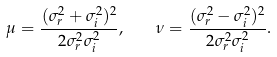Convert formula to latex. <formula><loc_0><loc_0><loc_500><loc_500>\mu = \frac { ( \sigma _ { r } ^ { 2 } + \sigma _ { i } ^ { 2 } ) ^ { 2 } } { 2 \sigma _ { r } ^ { 2 } \sigma _ { i } ^ { 2 } } , \quad \nu = \frac { ( \sigma _ { r } ^ { 2 } - \sigma _ { i } ^ { 2 } ) ^ { 2 } } { 2 \sigma _ { r } ^ { 2 } \sigma _ { i } ^ { 2 } } .</formula> 